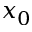<formula> <loc_0><loc_0><loc_500><loc_500>x _ { 0 }</formula> 